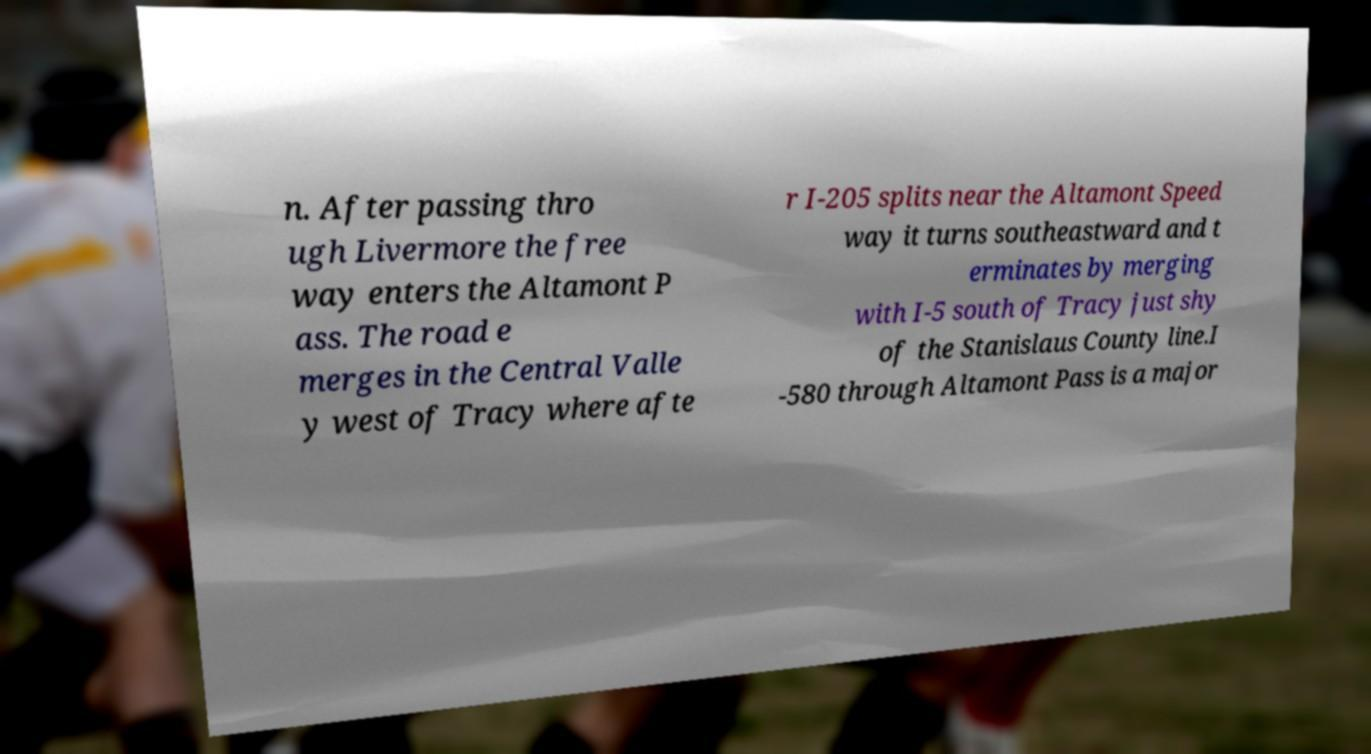Please read and relay the text visible in this image. What does it say? n. After passing thro ugh Livermore the free way enters the Altamont P ass. The road e merges in the Central Valle y west of Tracy where afte r I-205 splits near the Altamont Speed way it turns southeastward and t erminates by merging with I-5 south of Tracy just shy of the Stanislaus County line.I -580 through Altamont Pass is a major 